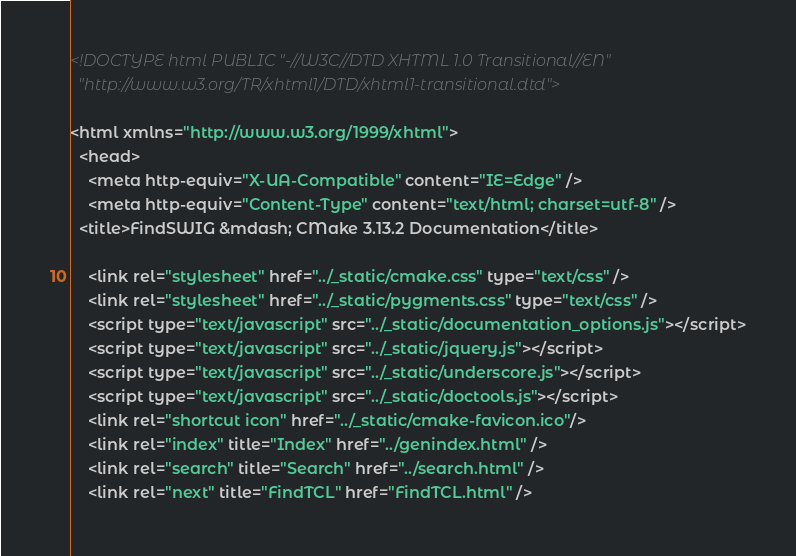<code> <loc_0><loc_0><loc_500><loc_500><_HTML_>
<!DOCTYPE html PUBLIC "-//W3C//DTD XHTML 1.0 Transitional//EN"
  "http://www.w3.org/TR/xhtml1/DTD/xhtml1-transitional.dtd">

<html xmlns="http://www.w3.org/1999/xhtml">
  <head>
    <meta http-equiv="X-UA-Compatible" content="IE=Edge" />
    <meta http-equiv="Content-Type" content="text/html; charset=utf-8" />
  <title>FindSWIG &mdash; CMake 3.13.2 Documentation</title>

    <link rel="stylesheet" href="../_static/cmake.css" type="text/css" />
    <link rel="stylesheet" href="../_static/pygments.css" type="text/css" />
    <script type="text/javascript" src="../_static/documentation_options.js"></script>
    <script type="text/javascript" src="../_static/jquery.js"></script>
    <script type="text/javascript" src="../_static/underscore.js"></script>
    <script type="text/javascript" src="../_static/doctools.js"></script>
    <link rel="shortcut icon" href="../_static/cmake-favicon.ico"/>
    <link rel="index" title="Index" href="../genindex.html" />
    <link rel="search" title="Search" href="../search.html" />
    <link rel="next" title="FindTCL" href="FindTCL.html" /></code> 